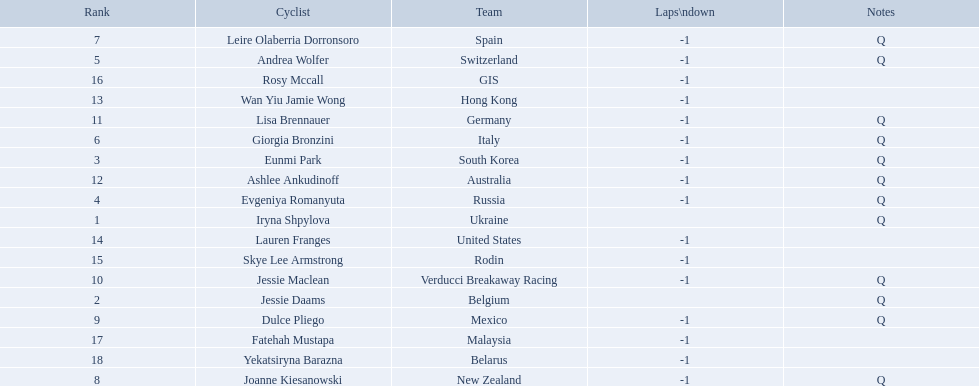Who are all of the cyclists in this race? Iryna Shpylova, Jessie Daams, Eunmi Park, Evgeniya Romanyuta, Andrea Wolfer, Giorgia Bronzini, Leire Olaberria Dorronsoro, Joanne Kiesanowski, Dulce Pliego, Jessie Maclean, Lisa Brennauer, Ashlee Ankudinoff, Wan Yiu Jamie Wong, Lauren Franges, Skye Lee Armstrong, Rosy Mccall, Fatehah Mustapa, Yekatsiryna Barazna. Of these, which one has the lowest numbered rank? Iryna Shpylova. Parse the full table. {'header': ['Rank', 'Cyclist', 'Team', 'Laps\\ndown', 'Notes'], 'rows': [['7', 'Leire Olaberria Dorronsoro', 'Spain', '-1', 'Q'], ['5', 'Andrea Wolfer', 'Switzerland', '-1', 'Q'], ['16', 'Rosy Mccall', 'GIS', '-1', ''], ['13', 'Wan Yiu Jamie Wong', 'Hong Kong', '-1', ''], ['11', 'Lisa Brennauer', 'Germany', '-1', 'Q'], ['6', 'Giorgia Bronzini', 'Italy', '-1', 'Q'], ['3', 'Eunmi Park', 'South Korea', '-1', 'Q'], ['12', 'Ashlee Ankudinoff', 'Australia', '-1', 'Q'], ['4', 'Evgeniya Romanyuta', 'Russia', '-1', 'Q'], ['1', 'Iryna Shpylova', 'Ukraine', '', 'Q'], ['14', 'Lauren Franges', 'United States', '-1', ''], ['15', 'Skye Lee Armstrong', 'Rodin', '-1', ''], ['10', 'Jessie Maclean', 'Verducci Breakaway Racing', '-1', 'Q'], ['2', 'Jessie Daams', 'Belgium', '', 'Q'], ['9', 'Dulce Pliego', 'Mexico', '-1', 'Q'], ['17', 'Fatehah Mustapa', 'Malaysia', '-1', ''], ['18', 'Yekatsiryna Barazna', 'Belarus', '-1', ''], ['8', 'Joanne Kiesanowski', 'New Zealand', '-1', 'Q']]} 